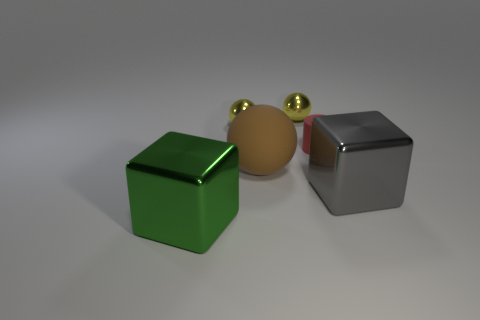Subtract 1 balls. How many balls are left? 2 Add 4 large blue matte cylinders. How many objects exist? 10 Subtract all cubes. How many objects are left? 4 Add 2 large green metal things. How many large green metal things are left? 3 Add 1 yellow objects. How many yellow objects exist? 3 Subtract 0 cyan cylinders. How many objects are left? 6 Subtract all metal things. Subtract all large metal blocks. How many objects are left? 0 